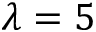Convert formula to latex. <formula><loc_0><loc_0><loc_500><loc_500>\lambda = 5</formula> 